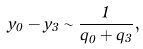Convert formula to latex. <formula><loc_0><loc_0><loc_500><loc_500>y _ { 0 } - y _ { 3 } \sim \frac { 1 } { q _ { 0 } + q _ { 3 } } ,</formula> 